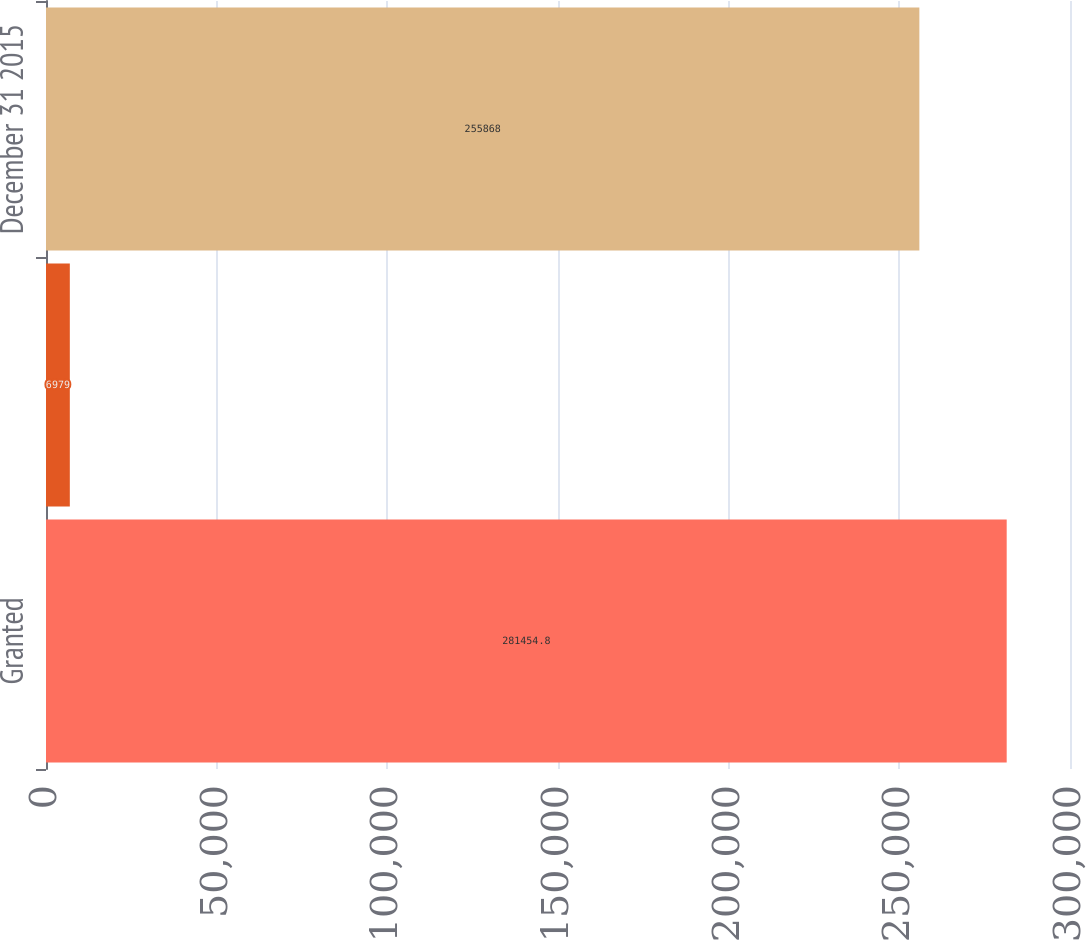Convert chart. <chart><loc_0><loc_0><loc_500><loc_500><bar_chart><fcel>Granted<fcel>Forfeited<fcel>December 31 2015<nl><fcel>281455<fcel>6979<fcel>255868<nl></chart> 